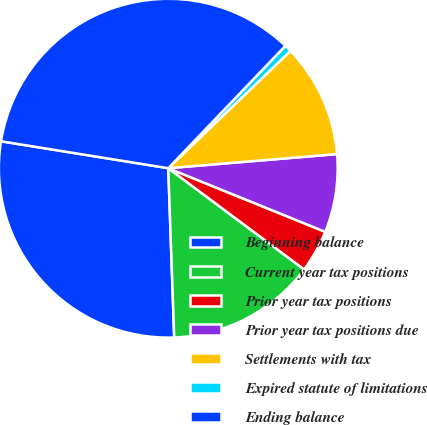Convert chart to OTSL. <chart><loc_0><loc_0><loc_500><loc_500><pie_chart><fcel>Beginning balance<fcel>Current year tax positions<fcel>Prior year tax positions<fcel>Prior year tax positions due<fcel>Settlements with tax<fcel>Expired statute of limitations<fcel>Ending balance<nl><fcel>28.1%<fcel>14.25%<fcel>4.06%<fcel>7.46%<fcel>10.85%<fcel>0.67%<fcel>34.61%<nl></chart> 